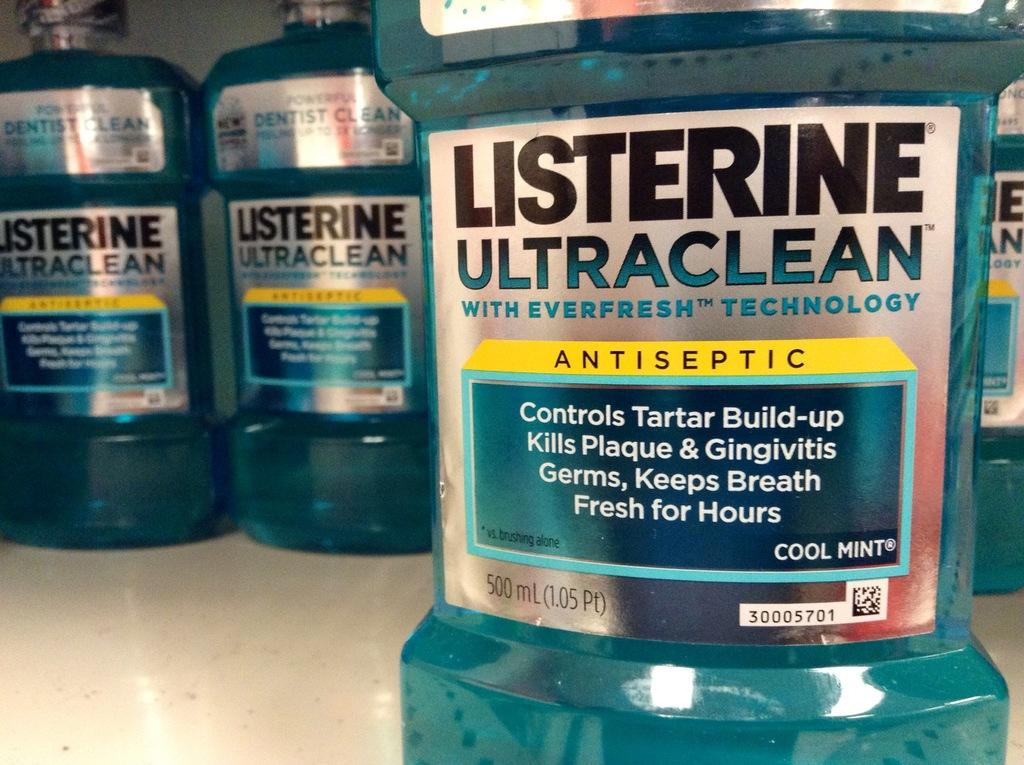<image>
Render a clear and concise summary of the photo. A bottle of Listerine is in front of several others. 